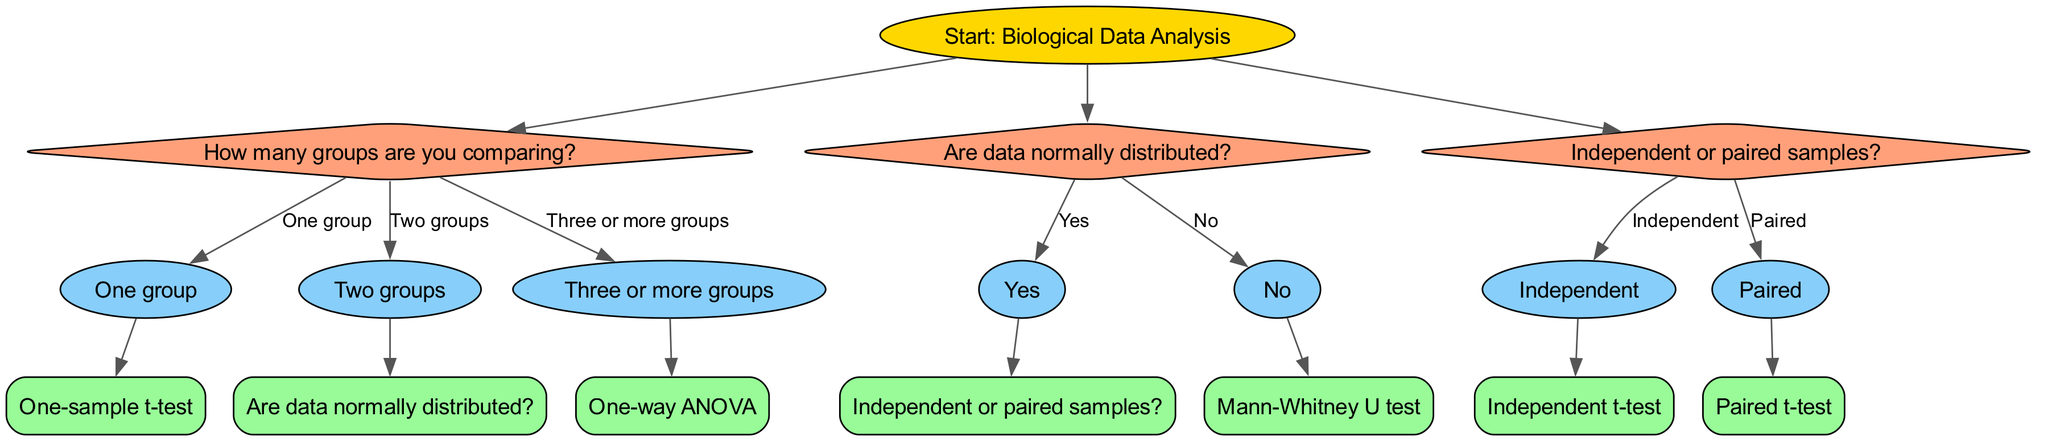What is the starting point of the decision tree? The starting point, which is the root node in the diagram, is clearly labeled as "Start: Biological Data Analysis". This indicates that the flow of the decision tree begins here.
Answer: Start: Biological Data Analysis How many options are available from the first question? The first question in the diagram is "How many groups are you comparing?". It has three different options listed: "One group", "Two groups", and "Three or more groups". Therefore, there are three options.
Answer: Three What is the endpoint for "Two groups" with normally distributed data? From "Two groups" the decision leads to "Are data normally distributed?". If the answer to this question is "Yes", then the next step is "Independent or paired samples?". The choices from there will determine the endpoint, but purely following "Yes" leads to "Independent or paired samples?". This flows into either an "Independent t-test" or a "Paired t-test".
Answer: Independent t-test or Paired t-test What statistical test is chosen if there is one group? If only one group is being analyzed, the decision path directly leads to the endpoint "One-sample t-test". This is a straightforward choice as there are no further questions or options to consider.
Answer: One-sample t-test What happens after determining "No" for normally distributed data when comparing two groups? If the data is determined to not be normally distributed after answering "No" to the question "Are data normally distributed?", the diagram indicates that the statistical test to utilize is the "Mann-Whitney U test". This is the direct conclusion after this point.
Answer: Mann-Whitney U test Which pathway leads to "One-way ANOVA"? The pathway to "One-way ANOVA" starts at the root with the question "How many groups are you comparing?". If the respondent selects "Three or more groups", it leads directly to the endpoint "One-way ANOVA" without further branching.
Answer: Three or more groups What is the next step if you answer "Paired" after inquiring about sample types? Following the question "Independent or paired samples?", if the user answers "Paired", the diagram directs you to "Paired t-test". This definitive outcome follows from choosing "Paired".
Answer: Paired t-test How many total endpoints are presented in this decision tree? The decision tree concludes after a number of options, and each unique endpoint is counted. The endpoints listed are: "One-sample t-test", "Independent t-test", "Paired t-test", "Mann-Whitney U test", and "One-way ANOVA". There are five distinct endpoints overall.
Answer: Five 